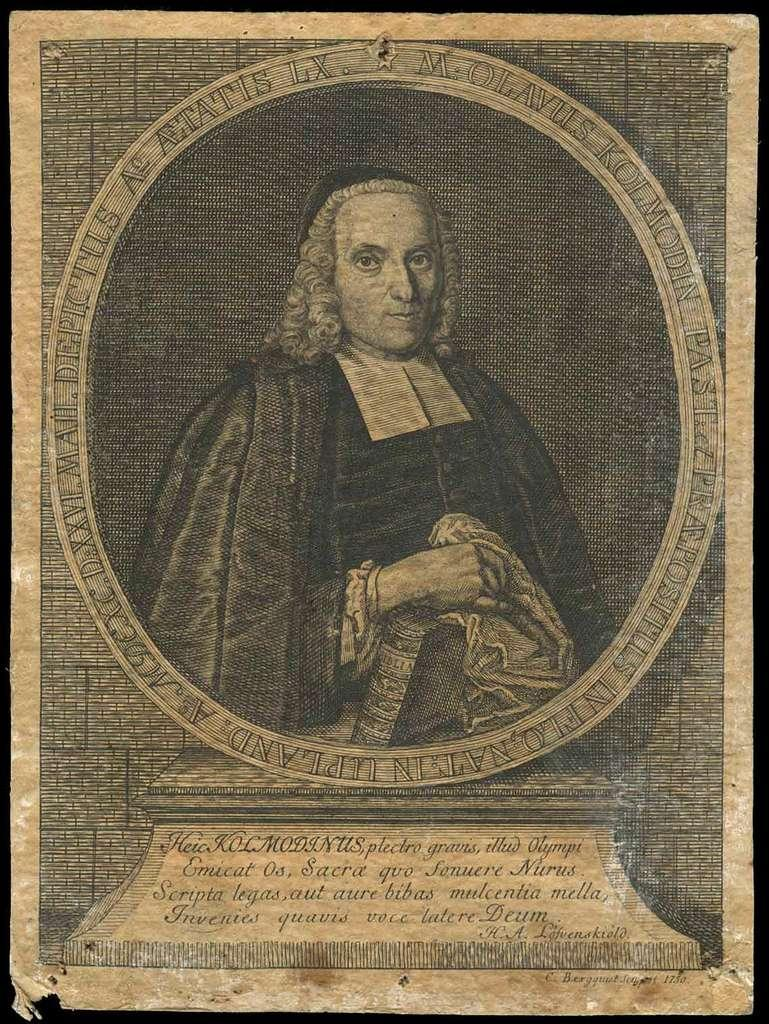<image>
Present a compact description of the photo's key features. A poster with a man and the saying Heia Kolmodinus on it. 